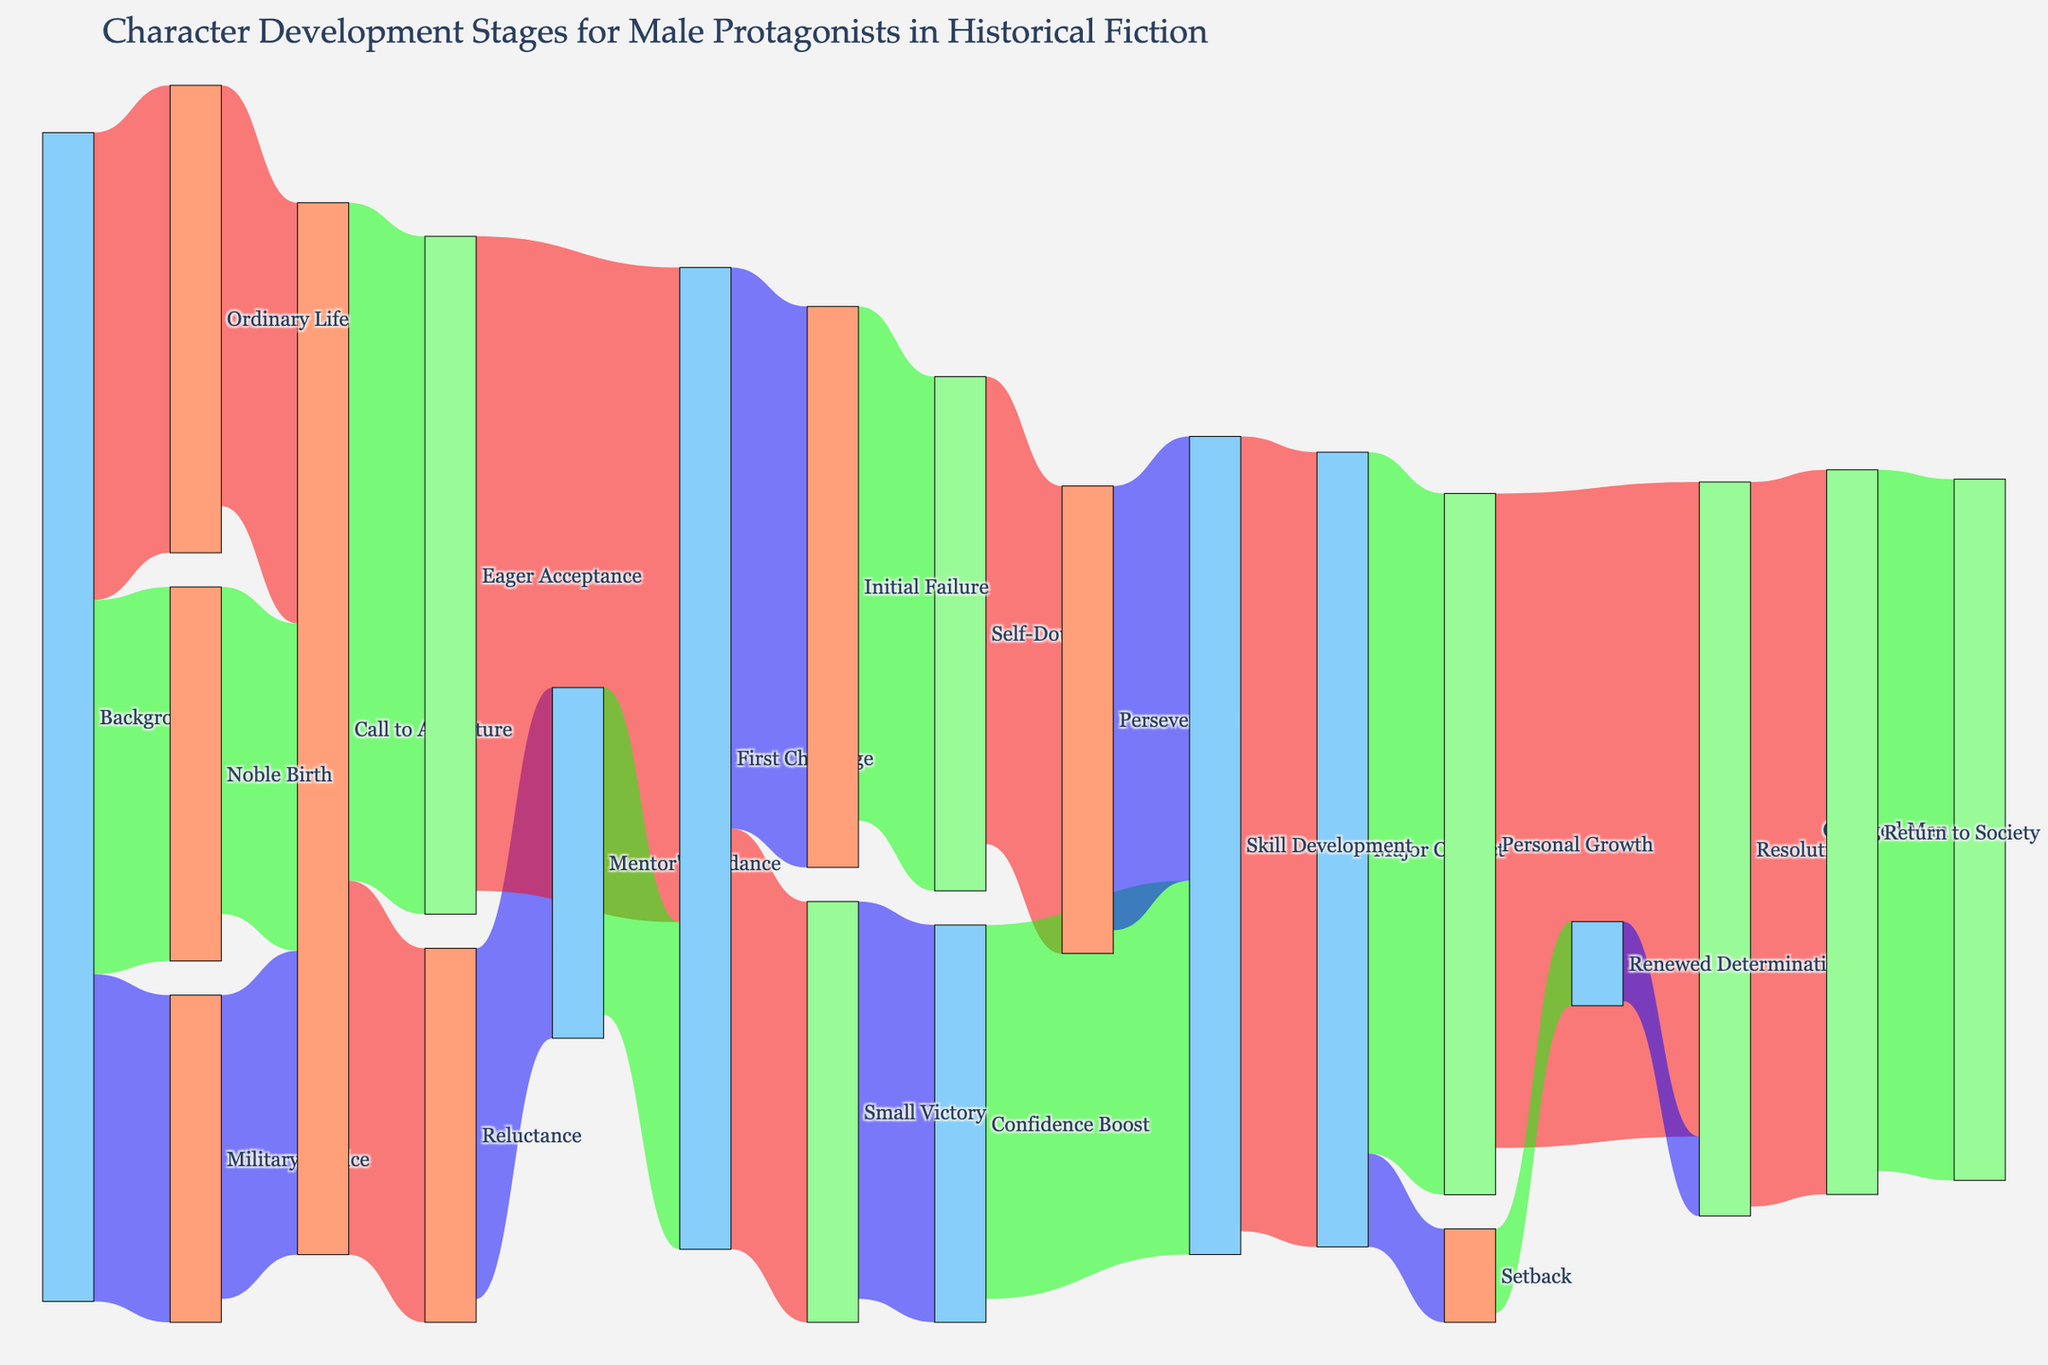What's the starting stage with the highest value? To determine this, look at the diagram's initial connections coming from the 'Background' stage. The links from 'Background' to other stages show 'Ordinary Life' has the highest value of 100.
Answer: Ordinary Life What are the distinct stages the character experiences after 'Call to Adventure'? Trace the paths emanating from 'Call to Adventure'. The stages are 'Reluctance' and 'Eager Acceptance'.
Answer: Reluctance, Eager Acceptance Which stage has more characters transitioning from 'First Challenge': 'Initial Failure' or 'Small Victory'? Follow the connections from 'First Challenge'. The value for 'Initial Failure' is 120, while for 'Small Victory' it is 90. Therefore, 'Initial Failure' has more characters.
Answer: Initial Failure How many characters end up in the 'Resolution' stage? Characters reach 'Resolution' from 'Personal Growth' and 'Renewed Determination'. By adding these values, 140 from 'Personal Growth' and 17 from 'Renewed Determination', the sum is 157.
Answer: 157 Compare the number of characters who start with 'Noble Birth' versus those who start with 'Military Service'. Which is higher? From the data, 'Noble Birth' has a value of 80 while 'Military Service' has a value of 70. Thus, 'Noble Birth' is higher.
Answer: Noble Birth What's the sum of characters who transitioned from 'First Challenge' to 'Skill Development'? Characters reach 'Skill Development' from 'Confidence Boost', 'Self-Doubt', and 'Perseverance'. By adding these values, 80 from 'Confidence Boost', 95 from 'Perseverance', the sum totals 175.
Answer: 175 What is the value difference between 'Personal Growth' and 'Setback' transitions from 'Major Conflict'? From 'Major Conflict', 'Personal Growth' has a value of 150 and 'Setback' has a value of 20. The difference between the two is 150 - 20 = 130.
Answer: 130 How many stages have a direct transition into 'Resolution'? The stages leading directly to 'Resolution' are 'Personal Growth' and 'Renewed Determination'. Counting these gives us 2 stages.
Answer: 2 Which path contains the highest single value in the entire plot? The largest value in the plot is found by checking all the link values. The highest single value is the transition from 'Eager Acceptance' to 'First Challenge' with 140.
Answer: Eager Acceptance to First Challenge 